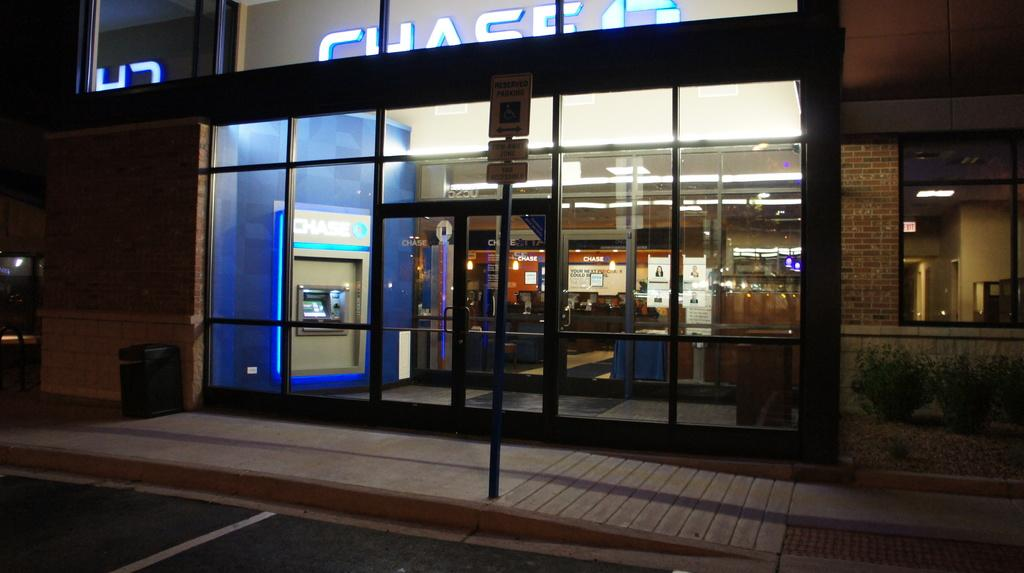<image>
Render a clear and concise summary of the photo. Then entrance to a building that has a Chase bank inside. 